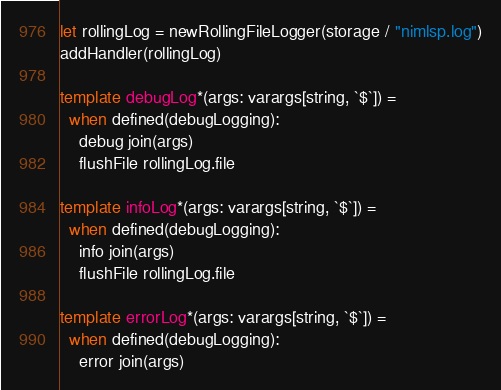Convert code to text. <code><loc_0><loc_0><loc_500><loc_500><_Nim_>let rollingLog = newRollingFileLogger(storage / "nimlsp.log")
addHandler(rollingLog)

template debugLog*(args: varargs[string, `$`]) =
  when defined(debugLogging):
    debug join(args)
    flushFile rollingLog.file

template infoLog*(args: varargs[string, `$`]) =
  when defined(debugLogging):
    info join(args)
    flushFile rollingLog.file

template errorLog*(args: varargs[string, `$`]) =
  when defined(debugLogging):
    error join(args)
</code> 